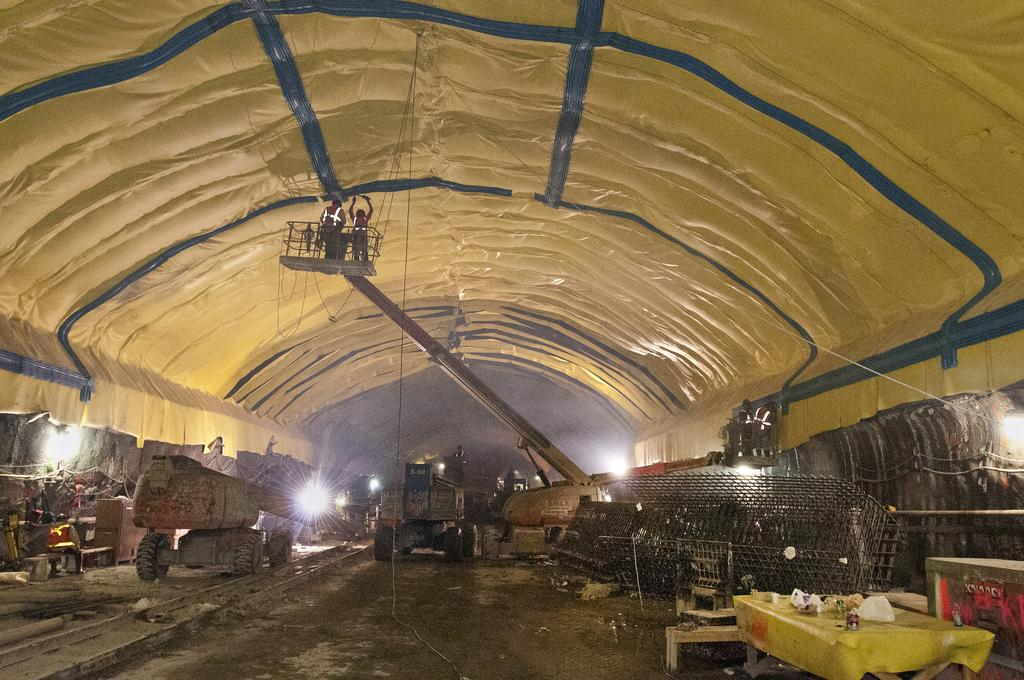Where was the image taken? The image was taken inside a godown. What can be seen on the land in the image? There are vehicles on the land in the image. What else is present near the vehicles? There are equipments on either side of the vehicles. What can be seen in the background of the image? There are lights visible in the background of the image. What number is being taught in the image? There is no indication of any learning or teaching activity in the image. What channel is being broadcasted on the television in the image? There is no television present in the image. 